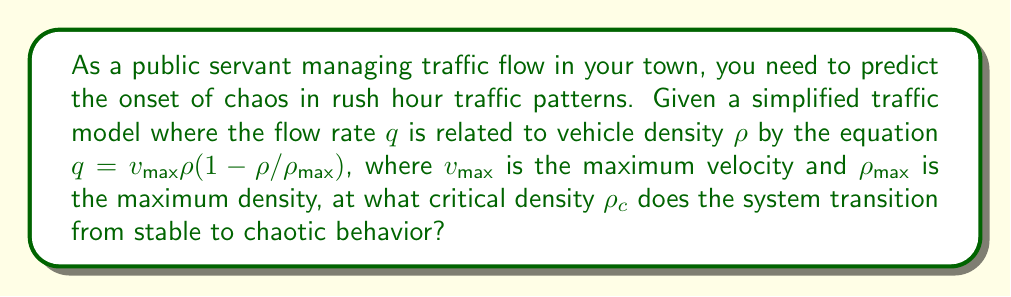Teach me how to tackle this problem. To determine the critical density where chaos onset occurs, we need to analyze the stability of the traffic flow model:

1) The given equation represents the fundamental diagram of traffic flow:
   $$q = v_{\text{max}}\rho(1-\rho/\rho_{\text{max}})$$

2) To find the point of instability, we need to find the maximum of this function. We can do this by differentiating $q$ with respect to $\rho$ and setting it to zero:

   $$\frac{dq}{d\rho} = v_{\text{max}}(1-2\rho/\rho_{\text{max}}) = 0$$

3) Solving this equation:
   $$1-2\rho/\rho_{\text{max}} = 0$$
   $$2\rho/\rho_{\text{max}} = 1$$
   $$\rho = \rho_{\text{max}}/2$$

4) This point, where $\rho = \rho_{\text{max}}/2$, represents the critical density $\rho_c$ where the system transitions from stable to unstable behavior.

5) In terms of bifurcation theory, this point represents a bifurcation point where the system's behavior qualitatively changes. Beyond this point, small perturbations can lead to large, unpredictable changes in traffic flow, indicative of chaotic behavior.

6) Therefore, the critical density $\rho_c$ at which chaos onset occurs is half of the maximum density $\rho_{\text{max}}$.
Answer: $\rho_c = \rho_{\text{max}}/2$ 